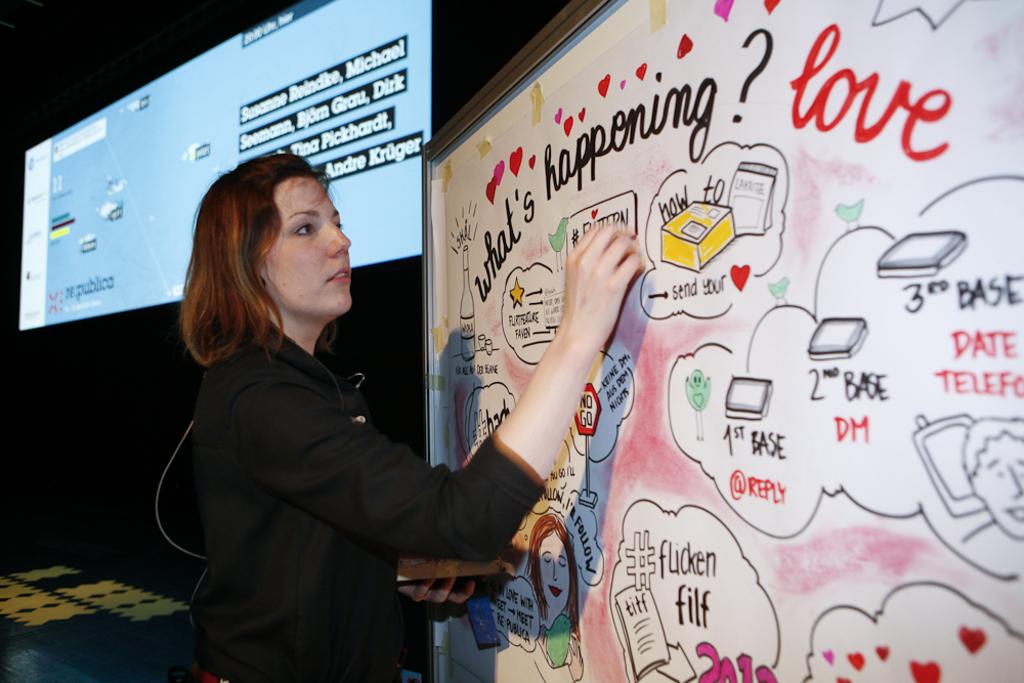What is written next to the hashtag symbol?
Give a very brief answer. Flicken filf. 